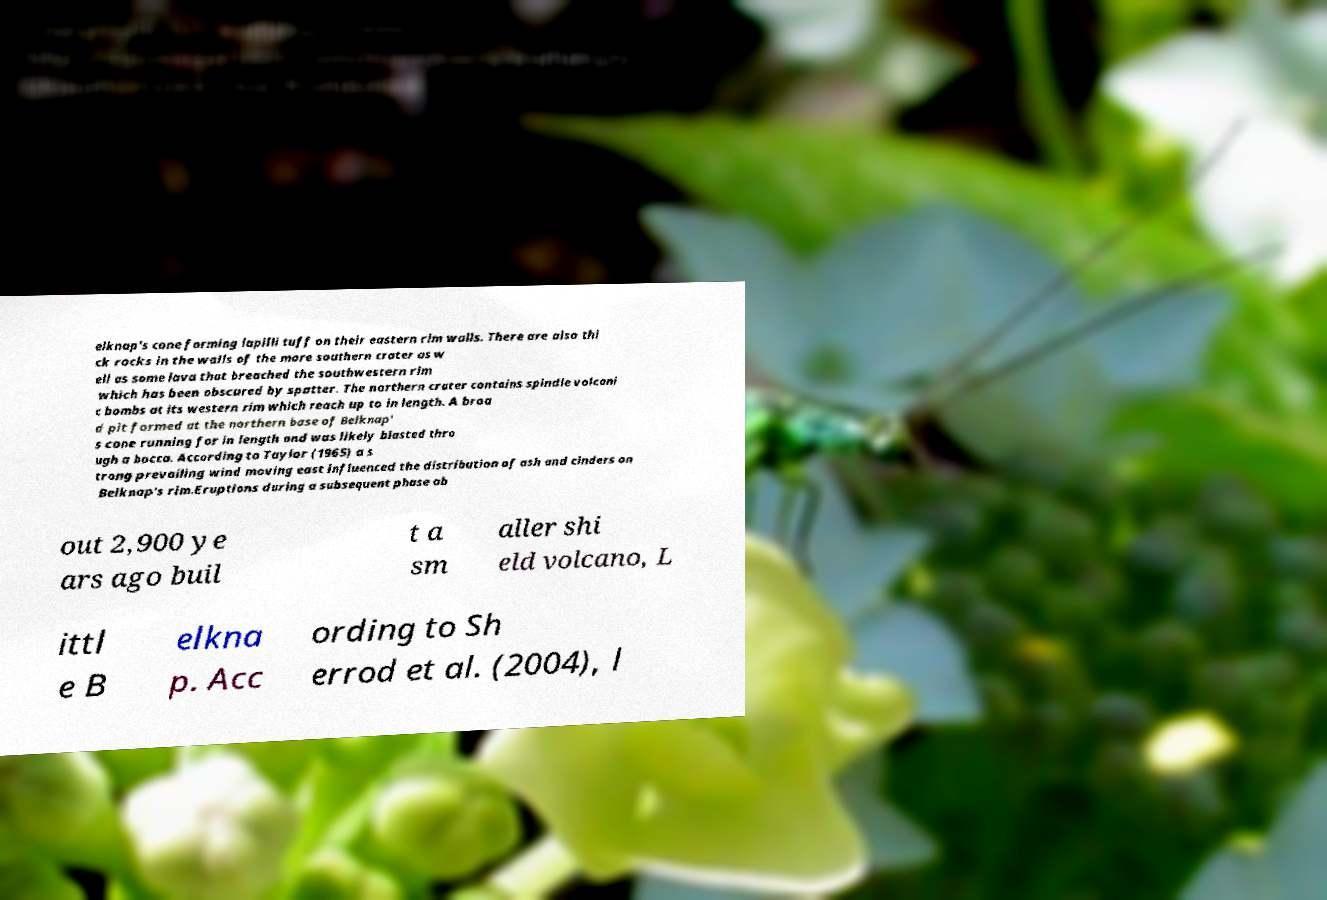For documentation purposes, I need the text within this image transcribed. Could you provide that? elknap's cone forming lapilli tuff on their eastern rim walls. There are also thi ck rocks in the walls of the more southern crater as w ell as some lava that breached the southwestern rim which has been obscured by spatter. The northern crater contains spindle volcani c bombs at its western rim which reach up to in length. A broa d pit formed at the northern base of Belknap' s cone running for in length and was likely blasted thro ugh a bocca. According to Taylor (1965) a s trong prevailing wind moving east influenced the distribution of ash and cinders on Belknap's rim.Eruptions during a subsequent phase ab out 2,900 ye ars ago buil t a sm aller shi eld volcano, L ittl e B elkna p. Acc ording to Sh errod et al. (2004), l 